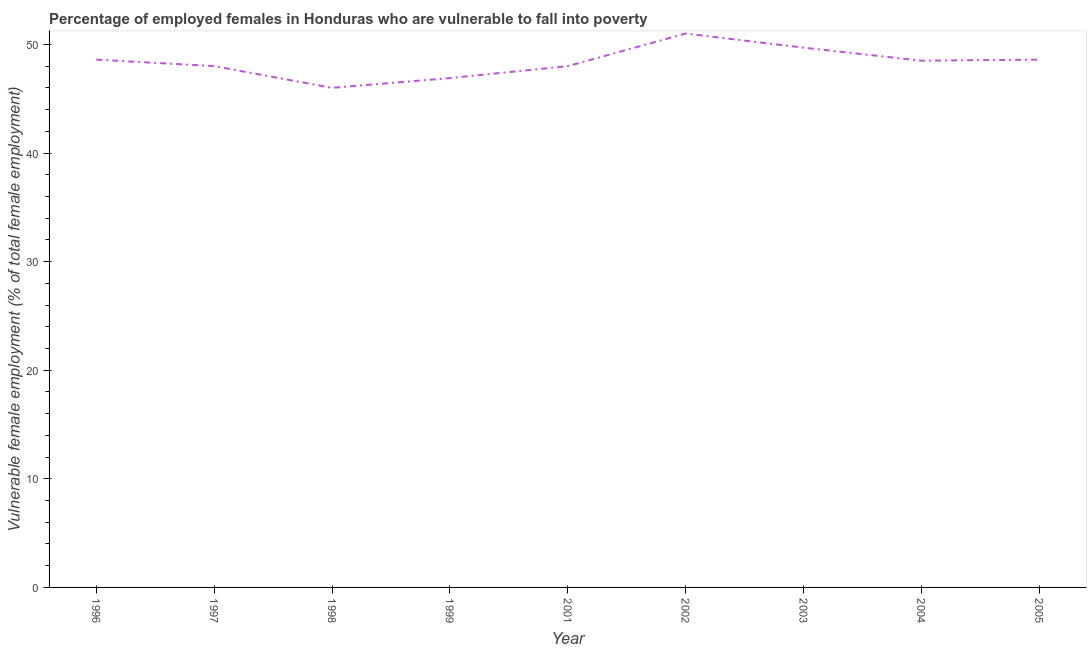What is the percentage of employed females who are vulnerable to fall into poverty in 2004?
Your response must be concise. 48.5. Across all years, what is the minimum percentage of employed females who are vulnerable to fall into poverty?
Your answer should be very brief. 46. In which year was the percentage of employed females who are vulnerable to fall into poverty minimum?
Give a very brief answer. 1998. What is the sum of the percentage of employed females who are vulnerable to fall into poverty?
Offer a very short reply. 435.3. What is the difference between the percentage of employed females who are vulnerable to fall into poverty in 2004 and 2005?
Keep it short and to the point. -0.1. What is the average percentage of employed females who are vulnerable to fall into poverty per year?
Make the answer very short. 48.37. What is the median percentage of employed females who are vulnerable to fall into poverty?
Offer a terse response. 48.5. In how many years, is the percentage of employed females who are vulnerable to fall into poverty greater than 38 %?
Provide a succinct answer. 9. Do a majority of the years between 1998 and 2003 (inclusive) have percentage of employed females who are vulnerable to fall into poverty greater than 24 %?
Offer a very short reply. Yes. What is the ratio of the percentage of employed females who are vulnerable to fall into poverty in 1997 to that in 2005?
Make the answer very short. 0.99. What is the difference between the highest and the second highest percentage of employed females who are vulnerable to fall into poverty?
Your answer should be compact. 1.3. Is the sum of the percentage of employed females who are vulnerable to fall into poverty in 1999 and 2003 greater than the maximum percentage of employed females who are vulnerable to fall into poverty across all years?
Your response must be concise. Yes. What is the difference between the highest and the lowest percentage of employed females who are vulnerable to fall into poverty?
Provide a short and direct response. 5. In how many years, is the percentage of employed females who are vulnerable to fall into poverty greater than the average percentage of employed females who are vulnerable to fall into poverty taken over all years?
Make the answer very short. 5. Does the percentage of employed females who are vulnerable to fall into poverty monotonically increase over the years?
Give a very brief answer. No. How many years are there in the graph?
Keep it short and to the point. 9. Are the values on the major ticks of Y-axis written in scientific E-notation?
Give a very brief answer. No. What is the title of the graph?
Ensure brevity in your answer.  Percentage of employed females in Honduras who are vulnerable to fall into poverty. What is the label or title of the Y-axis?
Offer a terse response. Vulnerable female employment (% of total female employment). What is the Vulnerable female employment (% of total female employment) of 1996?
Provide a short and direct response. 48.6. What is the Vulnerable female employment (% of total female employment) in 1997?
Provide a succinct answer. 48. What is the Vulnerable female employment (% of total female employment) of 1999?
Your answer should be compact. 46.9. What is the Vulnerable female employment (% of total female employment) of 2001?
Ensure brevity in your answer.  48. What is the Vulnerable female employment (% of total female employment) in 2002?
Give a very brief answer. 51. What is the Vulnerable female employment (% of total female employment) of 2003?
Your answer should be compact. 49.7. What is the Vulnerable female employment (% of total female employment) of 2004?
Your response must be concise. 48.5. What is the Vulnerable female employment (% of total female employment) of 2005?
Offer a very short reply. 48.6. What is the difference between the Vulnerable female employment (% of total female employment) in 1996 and 1997?
Ensure brevity in your answer.  0.6. What is the difference between the Vulnerable female employment (% of total female employment) in 1996 and 2002?
Keep it short and to the point. -2.4. What is the difference between the Vulnerable female employment (% of total female employment) in 1996 and 2004?
Offer a very short reply. 0.1. What is the difference between the Vulnerable female employment (% of total female employment) in 1996 and 2005?
Your answer should be compact. 0. What is the difference between the Vulnerable female employment (% of total female employment) in 1997 and 1998?
Provide a succinct answer. 2. What is the difference between the Vulnerable female employment (% of total female employment) in 1997 and 2002?
Provide a short and direct response. -3. What is the difference between the Vulnerable female employment (% of total female employment) in 1998 and 1999?
Provide a succinct answer. -0.9. What is the difference between the Vulnerable female employment (% of total female employment) in 1998 and 2001?
Make the answer very short. -2. What is the difference between the Vulnerable female employment (% of total female employment) in 1998 and 2005?
Provide a succinct answer. -2.6. What is the difference between the Vulnerable female employment (% of total female employment) in 1999 and 2003?
Make the answer very short. -2.8. What is the difference between the Vulnerable female employment (% of total female employment) in 1999 and 2005?
Provide a succinct answer. -1.7. What is the difference between the Vulnerable female employment (% of total female employment) in 2001 and 2005?
Your response must be concise. -0.6. What is the difference between the Vulnerable female employment (% of total female employment) in 2002 and 2003?
Keep it short and to the point. 1.3. What is the difference between the Vulnerable female employment (% of total female employment) in 2002 and 2005?
Give a very brief answer. 2.4. What is the difference between the Vulnerable female employment (% of total female employment) in 2003 and 2004?
Offer a terse response. 1.2. What is the difference between the Vulnerable female employment (% of total female employment) in 2003 and 2005?
Offer a terse response. 1.1. What is the ratio of the Vulnerable female employment (% of total female employment) in 1996 to that in 1997?
Your response must be concise. 1.01. What is the ratio of the Vulnerable female employment (% of total female employment) in 1996 to that in 1998?
Make the answer very short. 1.06. What is the ratio of the Vulnerable female employment (% of total female employment) in 1996 to that in 1999?
Offer a terse response. 1.04. What is the ratio of the Vulnerable female employment (% of total female employment) in 1996 to that in 2001?
Your response must be concise. 1.01. What is the ratio of the Vulnerable female employment (% of total female employment) in 1996 to that in 2002?
Provide a succinct answer. 0.95. What is the ratio of the Vulnerable female employment (% of total female employment) in 1996 to that in 2004?
Your answer should be compact. 1. What is the ratio of the Vulnerable female employment (% of total female employment) in 1996 to that in 2005?
Give a very brief answer. 1. What is the ratio of the Vulnerable female employment (% of total female employment) in 1997 to that in 1998?
Keep it short and to the point. 1.04. What is the ratio of the Vulnerable female employment (% of total female employment) in 1997 to that in 1999?
Offer a very short reply. 1.02. What is the ratio of the Vulnerable female employment (% of total female employment) in 1997 to that in 2002?
Offer a terse response. 0.94. What is the ratio of the Vulnerable female employment (% of total female employment) in 1997 to that in 2003?
Provide a short and direct response. 0.97. What is the ratio of the Vulnerable female employment (% of total female employment) in 1997 to that in 2005?
Your answer should be compact. 0.99. What is the ratio of the Vulnerable female employment (% of total female employment) in 1998 to that in 2001?
Ensure brevity in your answer.  0.96. What is the ratio of the Vulnerable female employment (% of total female employment) in 1998 to that in 2002?
Your answer should be very brief. 0.9. What is the ratio of the Vulnerable female employment (% of total female employment) in 1998 to that in 2003?
Provide a succinct answer. 0.93. What is the ratio of the Vulnerable female employment (% of total female employment) in 1998 to that in 2004?
Offer a very short reply. 0.95. What is the ratio of the Vulnerable female employment (% of total female employment) in 1998 to that in 2005?
Provide a succinct answer. 0.95. What is the ratio of the Vulnerable female employment (% of total female employment) in 1999 to that in 2002?
Your response must be concise. 0.92. What is the ratio of the Vulnerable female employment (% of total female employment) in 1999 to that in 2003?
Offer a terse response. 0.94. What is the ratio of the Vulnerable female employment (% of total female employment) in 1999 to that in 2004?
Give a very brief answer. 0.97. What is the ratio of the Vulnerable female employment (% of total female employment) in 1999 to that in 2005?
Your response must be concise. 0.96. What is the ratio of the Vulnerable female employment (% of total female employment) in 2001 to that in 2002?
Offer a terse response. 0.94. What is the ratio of the Vulnerable female employment (% of total female employment) in 2001 to that in 2004?
Provide a short and direct response. 0.99. What is the ratio of the Vulnerable female employment (% of total female employment) in 2001 to that in 2005?
Make the answer very short. 0.99. What is the ratio of the Vulnerable female employment (% of total female employment) in 2002 to that in 2003?
Keep it short and to the point. 1.03. What is the ratio of the Vulnerable female employment (% of total female employment) in 2002 to that in 2004?
Provide a short and direct response. 1.05. What is the ratio of the Vulnerable female employment (% of total female employment) in 2002 to that in 2005?
Your answer should be compact. 1.05. What is the ratio of the Vulnerable female employment (% of total female employment) in 2003 to that in 2005?
Provide a succinct answer. 1.02. 